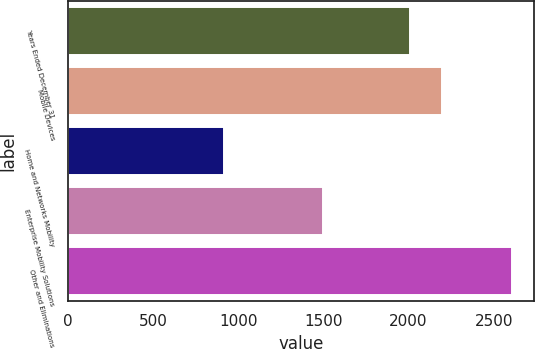Convert chart. <chart><loc_0><loc_0><loc_500><loc_500><bar_chart><fcel>Years Ended December 31<fcel>Mobile Devices<fcel>Home and Networks Mobility<fcel>Enterprise Mobility Solutions<fcel>Other and Eliminations<nl><fcel>2008<fcel>2199<fcel>918<fcel>1496<fcel>2606<nl></chart> 